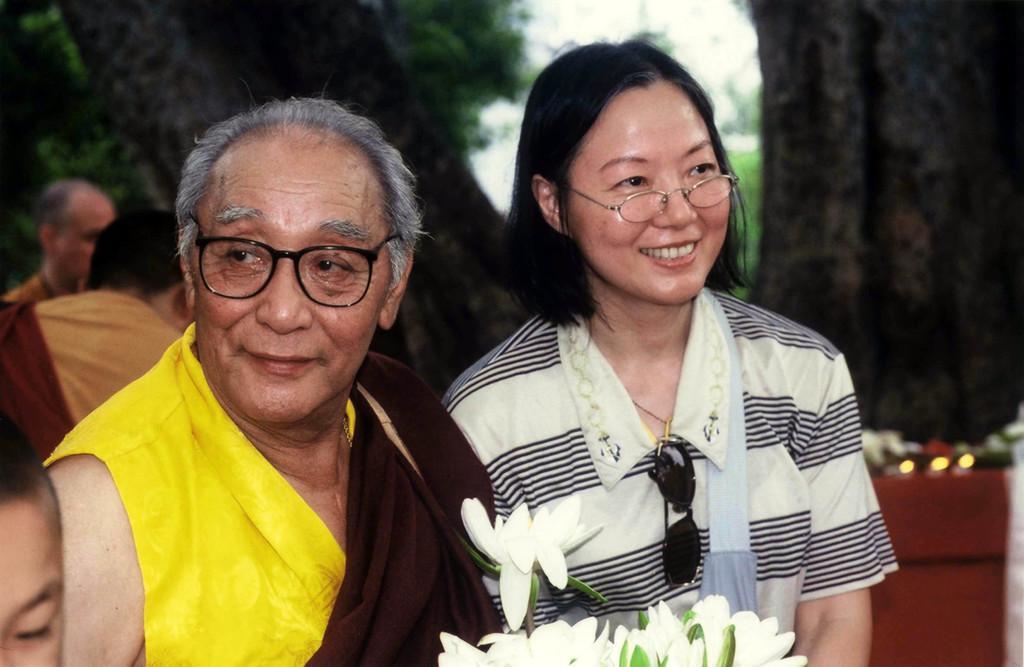In one or two sentences, can you explain what this image depicts? In this image there are two people wearing a smile on their faces. In front of them there are white flowers. Behind them there are few other people. In the background there are trees. 